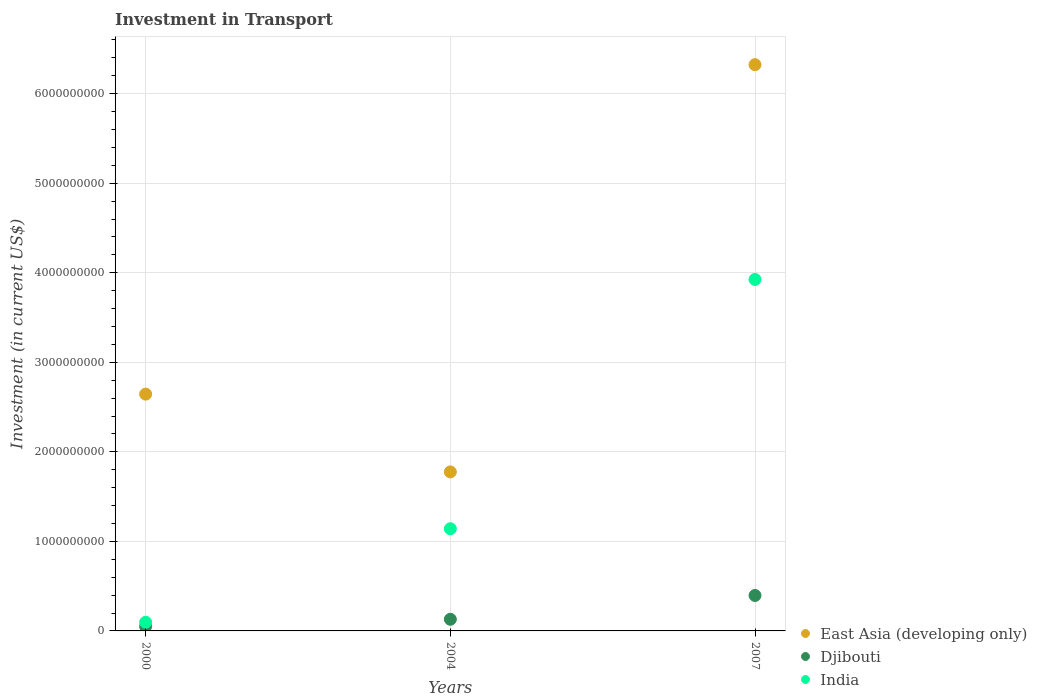How many different coloured dotlines are there?
Offer a very short reply. 3. What is the amount invested in transport in Djibouti in 2004?
Your answer should be very brief. 1.30e+08. Across all years, what is the maximum amount invested in transport in India?
Keep it short and to the point. 3.92e+09. Across all years, what is the minimum amount invested in transport in India?
Your response must be concise. 9.64e+07. In which year was the amount invested in transport in Djibouti maximum?
Make the answer very short. 2007. In which year was the amount invested in transport in India minimum?
Your response must be concise. 2000. What is the total amount invested in transport in India in the graph?
Ensure brevity in your answer.  5.16e+09. What is the difference between the amount invested in transport in India in 2004 and that in 2007?
Provide a short and direct response. -2.78e+09. What is the difference between the amount invested in transport in East Asia (developing only) in 2000 and the amount invested in transport in India in 2007?
Keep it short and to the point. -1.28e+09. What is the average amount invested in transport in Djibouti per year?
Ensure brevity in your answer.  1.92e+08. In the year 2004, what is the difference between the amount invested in transport in East Asia (developing only) and amount invested in transport in India?
Make the answer very short. 6.35e+08. What is the ratio of the amount invested in transport in East Asia (developing only) in 2000 to that in 2007?
Your response must be concise. 0.42. Is the amount invested in transport in Djibouti in 2004 less than that in 2007?
Your answer should be very brief. Yes. Is the difference between the amount invested in transport in East Asia (developing only) in 2000 and 2007 greater than the difference between the amount invested in transport in India in 2000 and 2007?
Offer a very short reply. Yes. What is the difference between the highest and the second highest amount invested in transport in India?
Your answer should be very brief. 2.78e+09. What is the difference between the highest and the lowest amount invested in transport in East Asia (developing only)?
Offer a very short reply. 4.55e+09. In how many years, is the amount invested in transport in East Asia (developing only) greater than the average amount invested in transport in East Asia (developing only) taken over all years?
Keep it short and to the point. 1. How many years are there in the graph?
Make the answer very short. 3. What is the difference between two consecutive major ticks on the Y-axis?
Offer a very short reply. 1.00e+09. Where does the legend appear in the graph?
Make the answer very short. Bottom right. How are the legend labels stacked?
Offer a very short reply. Vertical. What is the title of the graph?
Your answer should be compact. Investment in Transport. What is the label or title of the Y-axis?
Offer a terse response. Investment (in current US$). What is the Investment (in current US$) in East Asia (developing only) in 2000?
Keep it short and to the point. 2.64e+09. What is the Investment (in current US$) of India in 2000?
Keep it short and to the point. 9.64e+07. What is the Investment (in current US$) in East Asia (developing only) in 2004?
Ensure brevity in your answer.  1.78e+09. What is the Investment (in current US$) of Djibouti in 2004?
Make the answer very short. 1.30e+08. What is the Investment (in current US$) in India in 2004?
Your response must be concise. 1.14e+09. What is the Investment (in current US$) of East Asia (developing only) in 2007?
Keep it short and to the point. 6.32e+09. What is the Investment (in current US$) of Djibouti in 2007?
Your answer should be very brief. 3.96e+08. What is the Investment (in current US$) of India in 2007?
Your answer should be very brief. 3.92e+09. Across all years, what is the maximum Investment (in current US$) in East Asia (developing only)?
Provide a succinct answer. 6.32e+09. Across all years, what is the maximum Investment (in current US$) in Djibouti?
Your answer should be compact. 3.96e+08. Across all years, what is the maximum Investment (in current US$) of India?
Ensure brevity in your answer.  3.92e+09. Across all years, what is the minimum Investment (in current US$) of East Asia (developing only)?
Offer a terse response. 1.78e+09. Across all years, what is the minimum Investment (in current US$) in Djibouti?
Keep it short and to the point. 5.00e+07. Across all years, what is the minimum Investment (in current US$) of India?
Keep it short and to the point. 9.64e+07. What is the total Investment (in current US$) in East Asia (developing only) in the graph?
Make the answer very short. 1.07e+1. What is the total Investment (in current US$) of Djibouti in the graph?
Your response must be concise. 5.76e+08. What is the total Investment (in current US$) of India in the graph?
Offer a terse response. 5.16e+09. What is the difference between the Investment (in current US$) in East Asia (developing only) in 2000 and that in 2004?
Make the answer very short. 8.69e+08. What is the difference between the Investment (in current US$) of Djibouti in 2000 and that in 2004?
Keep it short and to the point. -8.00e+07. What is the difference between the Investment (in current US$) in India in 2000 and that in 2004?
Keep it short and to the point. -1.04e+09. What is the difference between the Investment (in current US$) of East Asia (developing only) in 2000 and that in 2007?
Ensure brevity in your answer.  -3.68e+09. What is the difference between the Investment (in current US$) of Djibouti in 2000 and that in 2007?
Ensure brevity in your answer.  -3.46e+08. What is the difference between the Investment (in current US$) in India in 2000 and that in 2007?
Your answer should be very brief. -3.83e+09. What is the difference between the Investment (in current US$) in East Asia (developing only) in 2004 and that in 2007?
Keep it short and to the point. -4.55e+09. What is the difference between the Investment (in current US$) in Djibouti in 2004 and that in 2007?
Ensure brevity in your answer.  -2.66e+08. What is the difference between the Investment (in current US$) of India in 2004 and that in 2007?
Your answer should be compact. -2.78e+09. What is the difference between the Investment (in current US$) of East Asia (developing only) in 2000 and the Investment (in current US$) of Djibouti in 2004?
Give a very brief answer. 2.51e+09. What is the difference between the Investment (in current US$) in East Asia (developing only) in 2000 and the Investment (in current US$) in India in 2004?
Your answer should be compact. 1.50e+09. What is the difference between the Investment (in current US$) in Djibouti in 2000 and the Investment (in current US$) in India in 2004?
Ensure brevity in your answer.  -1.09e+09. What is the difference between the Investment (in current US$) of East Asia (developing only) in 2000 and the Investment (in current US$) of Djibouti in 2007?
Your response must be concise. 2.25e+09. What is the difference between the Investment (in current US$) in East Asia (developing only) in 2000 and the Investment (in current US$) in India in 2007?
Keep it short and to the point. -1.28e+09. What is the difference between the Investment (in current US$) of Djibouti in 2000 and the Investment (in current US$) of India in 2007?
Provide a succinct answer. -3.87e+09. What is the difference between the Investment (in current US$) of East Asia (developing only) in 2004 and the Investment (in current US$) of Djibouti in 2007?
Your answer should be compact. 1.38e+09. What is the difference between the Investment (in current US$) in East Asia (developing only) in 2004 and the Investment (in current US$) in India in 2007?
Your answer should be very brief. -2.15e+09. What is the difference between the Investment (in current US$) of Djibouti in 2004 and the Investment (in current US$) of India in 2007?
Your answer should be very brief. -3.79e+09. What is the average Investment (in current US$) of East Asia (developing only) per year?
Offer a very short reply. 3.58e+09. What is the average Investment (in current US$) in Djibouti per year?
Keep it short and to the point. 1.92e+08. What is the average Investment (in current US$) of India per year?
Provide a succinct answer. 1.72e+09. In the year 2000, what is the difference between the Investment (in current US$) of East Asia (developing only) and Investment (in current US$) of Djibouti?
Your response must be concise. 2.59e+09. In the year 2000, what is the difference between the Investment (in current US$) in East Asia (developing only) and Investment (in current US$) in India?
Your answer should be compact. 2.55e+09. In the year 2000, what is the difference between the Investment (in current US$) of Djibouti and Investment (in current US$) of India?
Provide a succinct answer. -4.64e+07. In the year 2004, what is the difference between the Investment (in current US$) in East Asia (developing only) and Investment (in current US$) in Djibouti?
Make the answer very short. 1.65e+09. In the year 2004, what is the difference between the Investment (in current US$) in East Asia (developing only) and Investment (in current US$) in India?
Offer a terse response. 6.35e+08. In the year 2004, what is the difference between the Investment (in current US$) in Djibouti and Investment (in current US$) in India?
Your response must be concise. -1.01e+09. In the year 2007, what is the difference between the Investment (in current US$) of East Asia (developing only) and Investment (in current US$) of Djibouti?
Offer a very short reply. 5.93e+09. In the year 2007, what is the difference between the Investment (in current US$) in East Asia (developing only) and Investment (in current US$) in India?
Ensure brevity in your answer.  2.40e+09. In the year 2007, what is the difference between the Investment (in current US$) in Djibouti and Investment (in current US$) in India?
Offer a very short reply. -3.53e+09. What is the ratio of the Investment (in current US$) of East Asia (developing only) in 2000 to that in 2004?
Ensure brevity in your answer.  1.49. What is the ratio of the Investment (in current US$) of Djibouti in 2000 to that in 2004?
Offer a very short reply. 0.38. What is the ratio of the Investment (in current US$) in India in 2000 to that in 2004?
Give a very brief answer. 0.08. What is the ratio of the Investment (in current US$) in East Asia (developing only) in 2000 to that in 2007?
Offer a very short reply. 0.42. What is the ratio of the Investment (in current US$) of Djibouti in 2000 to that in 2007?
Make the answer very short. 0.13. What is the ratio of the Investment (in current US$) in India in 2000 to that in 2007?
Your response must be concise. 0.02. What is the ratio of the Investment (in current US$) of East Asia (developing only) in 2004 to that in 2007?
Your response must be concise. 0.28. What is the ratio of the Investment (in current US$) in Djibouti in 2004 to that in 2007?
Offer a terse response. 0.33. What is the ratio of the Investment (in current US$) of India in 2004 to that in 2007?
Your answer should be very brief. 0.29. What is the difference between the highest and the second highest Investment (in current US$) of East Asia (developing only)?
Your answer should be compact. 3.68e+09. What is the difference between the highest and the second highest Investment (in current US$) in Djibouti?
Offer a terse response. 2.66e+08. What is the difference between the highest and the second highest Investment (in current US$) of India?
Offer a terse response. 2.78e+09. What is the difference between the highest and the lowest Investment (in current US$) in East Asia (developing only)?
Your answer should be compact. 4.55e+09. What is the difference between the highest and the lowest Investment (in current US$) in Djibouti?
Make the answer very short. 3.46e+08. What is the difference between the highest and the lowest Investment (in current US$) of India?
Make the answer very short. 3.83e+09. 